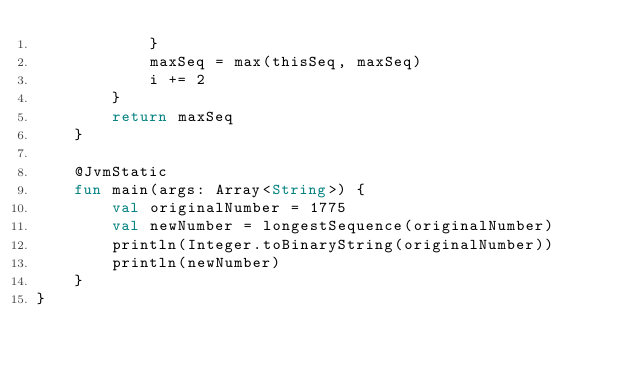Convert code to text. <code><loc_0><loc_0><loc_500><loc_500><_Kotlin_>            }
            maxSeq = max(thisSeq, maxSeq)
            i += 2
        }
        return maxSeq
    }

    @JvmStatic
    fun main(args: Array<String>) {
        val originalNumber = 1775
        val newNumber = longestSequence(originalNumber)
        println(Integer.toBinaryString(originalNumber))
        println(newNumber)
    }
}</code> 